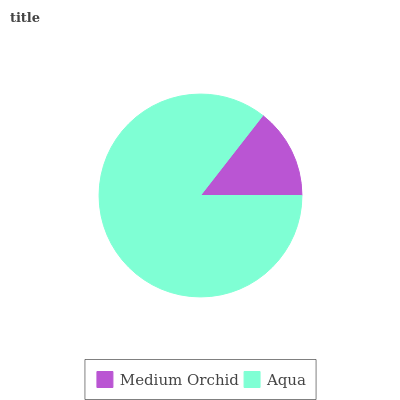Is Medium Orchid the minimum?
Answer yes or no. Yes. Is Aqua the maximum?
Answer yes or no. Yes. Is Aqua the minimum?
Answer yes or no. No. Is Aqua greater than Medium Orchid?
Answer yes or no. Yes. Is Medium Orchid less than Aqua?
Answer yes or no. Yes. Is Medium Orchid greater than Aqua?
Answer yes or no. No. Is Aqua less than Medium Orchid?
Answer yes or no. No. Is Aqua the high median?
Answer yes or no. Yes. Is Medium Orchid the low median?
Answer yes or no. Yes. Is Medium Orchid the high median?
Answer yes or no. No. Is Aqua the low median?
Answer yes or no. No. 